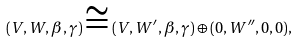Convert formula to latex. <formula><loc_0><loc_0><loc_500><loc_500>( V , W , \beta , \gamma ) \cong ( V , W ^ { \prime } , \beta , \gamma ) \oplus ( 0 , W ^ { \prime \prime } , 0 , 0 ) ,</formula> 